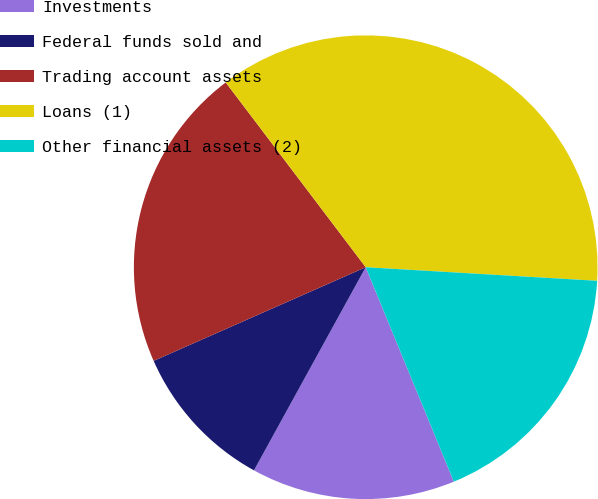<chart> <loc_0><loc_0><loc_500><loc_500><pie_chart><fcel>Investments<fcel>Federal funds sold and<fcel>Trading account assets<fcel>Loans (1)<fcel>Other financial assets (2)<nl><fcel>14.21%<fcel>10.38%<fcel>21.3%<fcel>36.25%<fcel>17.86%<nl></chart> 